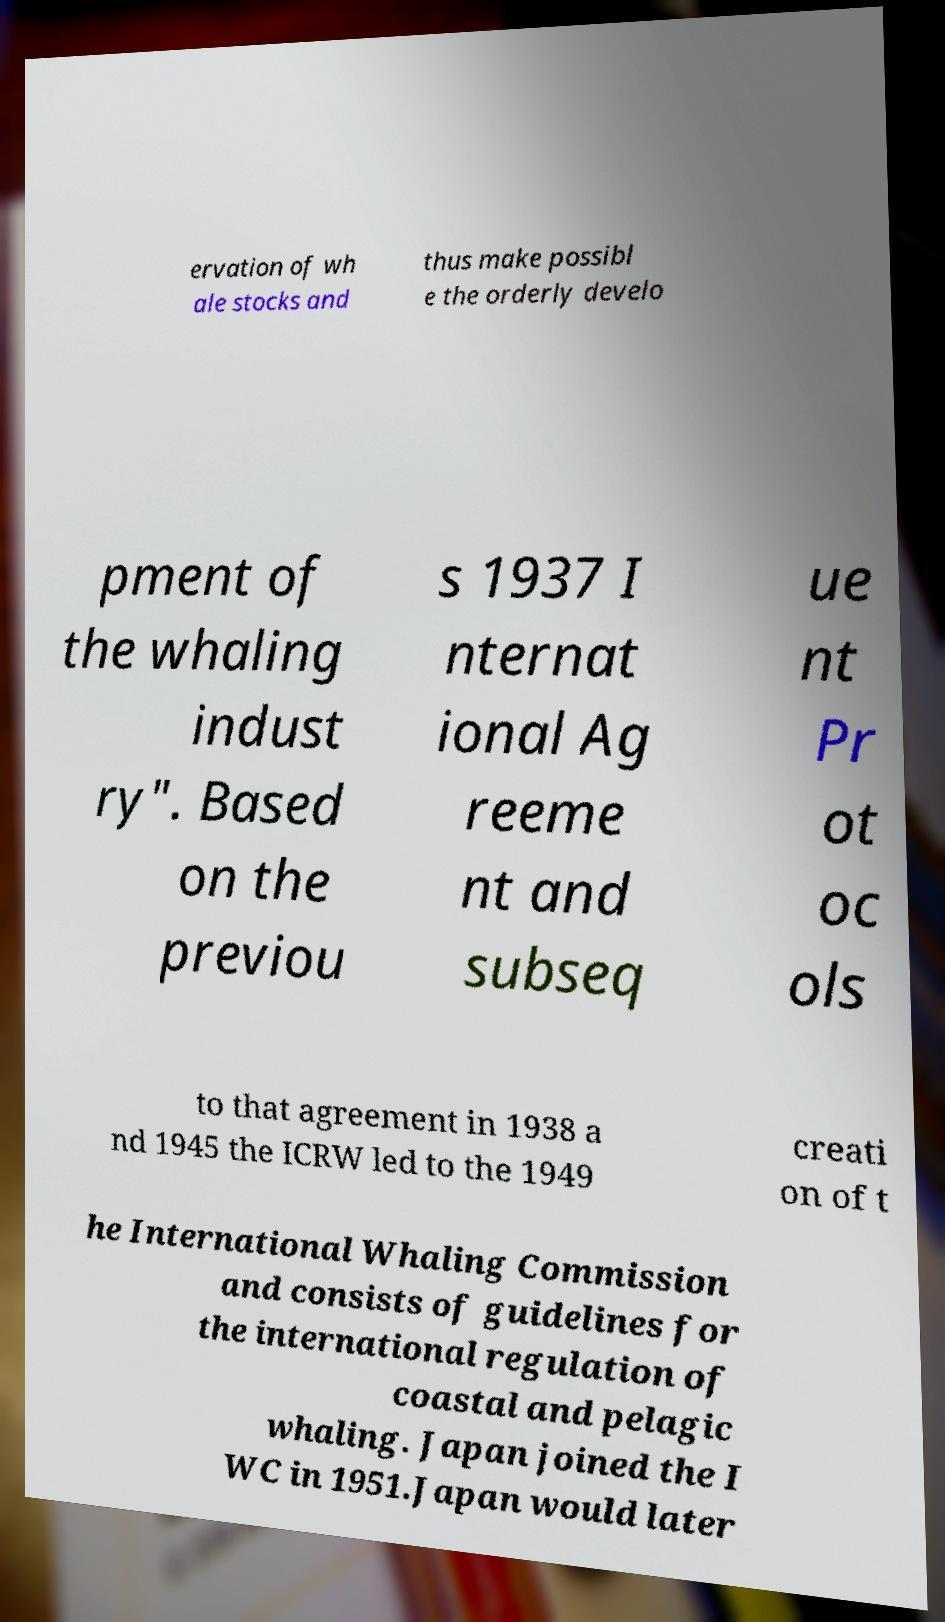Could you extract and type out the text from this image? ervation of wh ale stocks and thus make possibl e the orderly develo pment of the whaling indust ry". Based on the previou s 1937 I nternat ional Ag reeme nt and subseq ue nt Pr ot oc ols to that agreement in 1938 a nd 1945 the ICRW led to the 1949 creati on of t he International Whaling Commission and consists of guidelines for the international regulation of coastal and pelagic whaling. Japan joined the I WC in 1951.Japan would later 